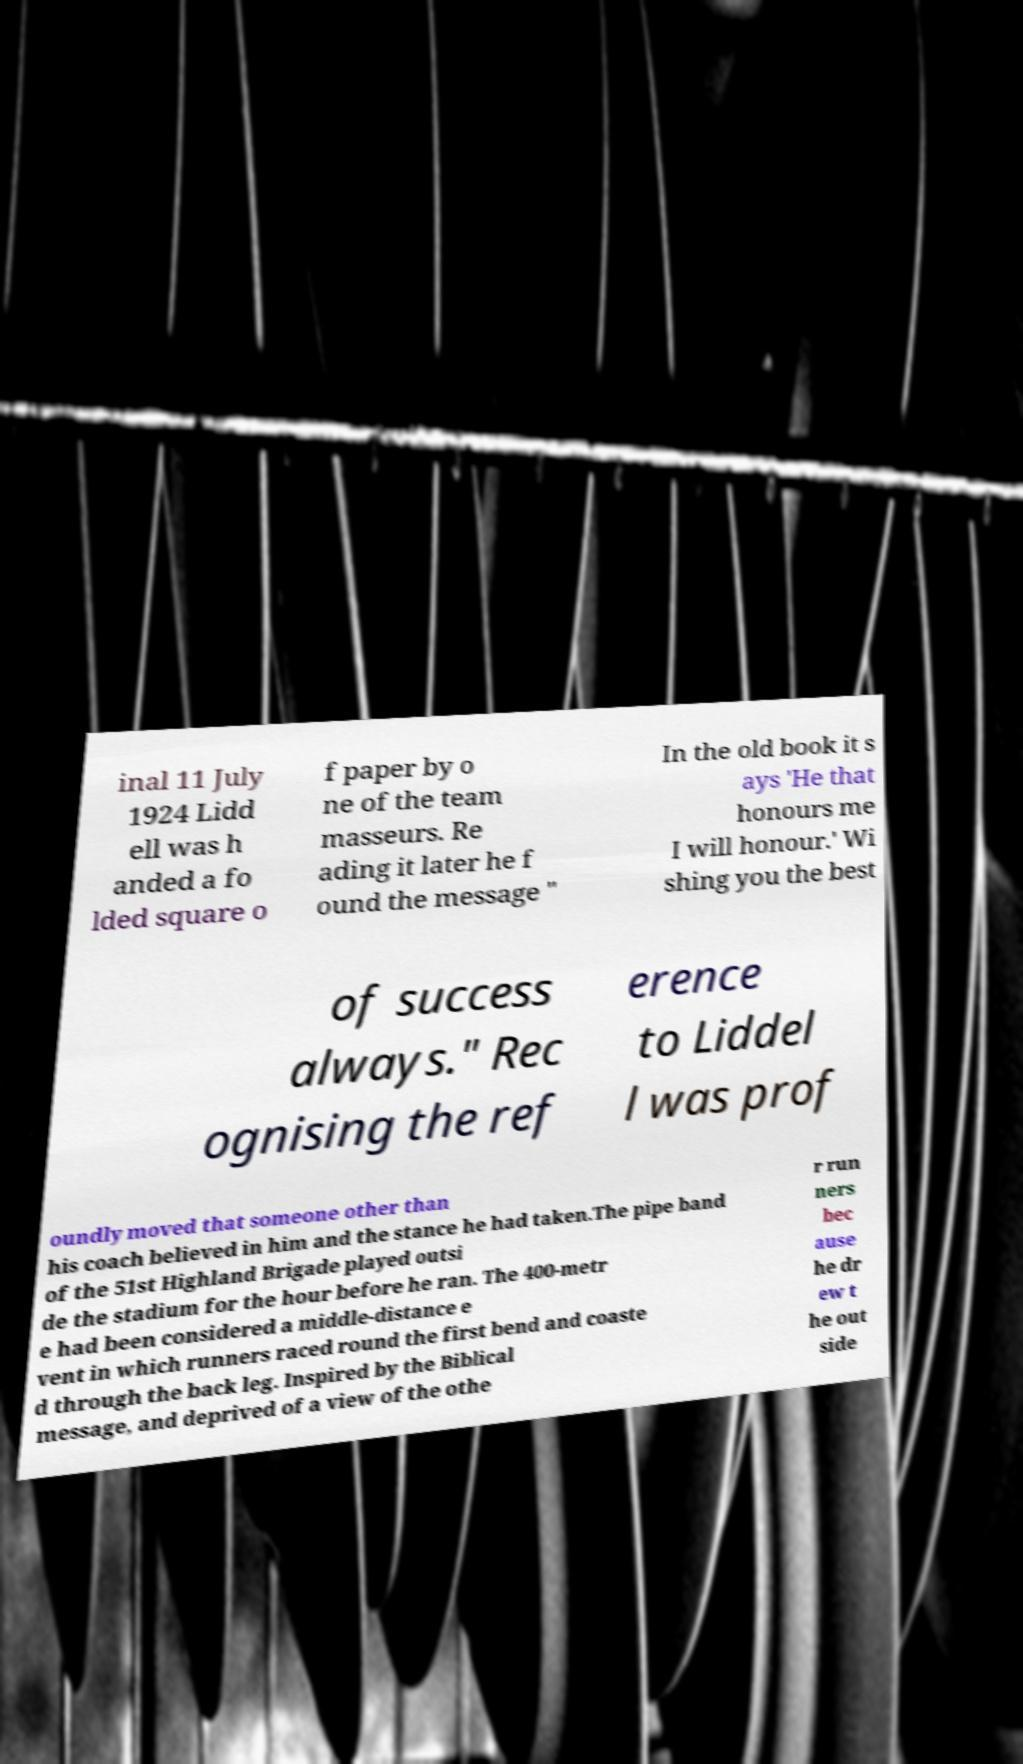Can you read and provide the text displayed in the image?This photo seems to have some interesting text. Can you extract and type it out for me? inal 11 July 1924 Lidd ell was h anded a fo lded square o f paper by o ne of the team masseurs. Re ading it later he f ound the message " In the old book it s ays 'He that honours me I will honour.' Wi shing you the best of success always." Rec ognising the ref erence to Liddel l was prof oundly moved that someone other than his coach believed in him and the stance he had taken.The pipe band of the 51st Highland Brigade played outsi de the stadium for the hour before he ran. The 400-metr e had been considered a middle-distance e vent in which runners raced round the first bend and coaste d through the back leg. Inspired by the Biblical message, and deprived of a view of the othe r run ners bec ause he dr ew t he out side 